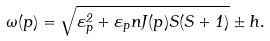Convert formula to latex. <formula><loc_0><loc_0><loc_500><loc_500>\omega ( { p } ) = \sqrt { \varepsilon _ { p } ^ { 2 } + \varepsilon _ { p } n J ( { p } ) S ( S + 1 ) } \pm h .</formula> 